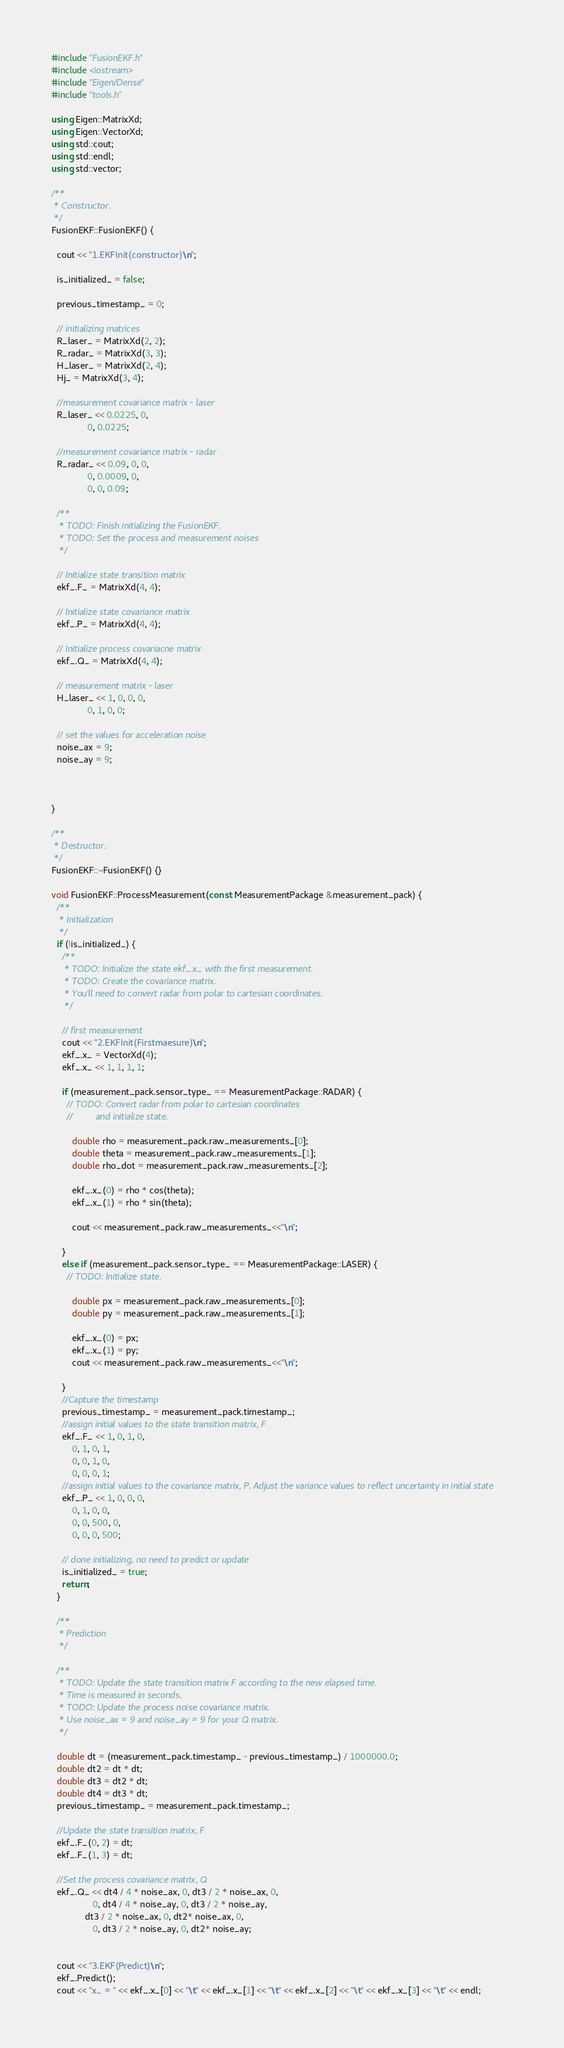Convert code to text. <code><loc_0><loc_0><loc_500><loc_500><_C++_>#include "FusionEKF.h"
#include <iostream>
#include "Eigen/Dense"
#include "tools.h"

using Eigen::MatrixXd;
using Eigen::VectorXd;
using std::cout;
using std::endl;
using std::vector;

/**
 * Constructor.
 */
FusionEKF::FusionEKF() {
  
  cout << "1.EKFInit(constructor)\n";
    
  is_initialized_ = false;

  previous_timestamp_ = 0;

  // initializing matrices
  R_laser_ = MatrixXd(2, 2);
  R_radar_ = MatrixXd(3, 3);
  H_laser_ = MatrixXd(2, 4);
  Hj_ = MatrixXd(3, 4);

  //measurement covariance matrix - laser
  R_laser_ << 0.0225, 0,
              0, 0.0225;

  //measurement covariance matrix - radar
  R_radar_ << 0.09, 0, 0,
              0, 0.0009, 0,
              0, 0, 0.09;

  /**
   * TODO: Finish initializing the FusionEKF.
   * TODO: Set the process and measurement noises
   */

  // Initialize state transition matrix
  ekf_.F_ = MatrixXd(4, 4);

  // Initialize state covariance matrix
  ekf_.P_ = MatrixXd(4, 4);

  // Initialize process covariacne matrix
  ekf_.Q_ = MatrixXd(4, 4);

  // measurement matrix - laser
  H_laser_ << 1, 0, 0, 0,
              0, 1, 0, 0;
  
  // set the values for acceleration noise
  noise_ax = 9;
  noise_ay = 9;



}

/**
 * Destructor.
 */
FusionEKF::~FusionEKF() {}

void FusionEKF::ProcessMeasurement(const MeasurementPackage &measurement_pack) {
  /**
   * Initialization
   */
  if (!is_initialized_) {
    /**
     * TODO: Initialize the state ekf_.x_ with the first measurement.
     * TODO: Create the covariance matrix.
     * You'll need to convert radar from polar to cartesian coordinates.
     */

    // first measurement
    cout << "2.EKFInit(Firstmaesure)\n";
    ekf_.x_ = VectorXd(4);
    ekf_.x_ << 1, 1, 1, 1;

    if (measurement_pack.sensor_type_ == MeasurementPackage::RADAR) {
      // TODO: Convert radar from polar to cartesian coordinates 
      //         and initialize state.

        double rho = measurement_pack.raw_measurements_[0];
        double theta = measurement_pack.raw_measurements_[1];
        double rho_dot = measurement_pack.raw_measurements_[2];
       
        ekf_.x_(0) = rho * cos(theta);
        ekf_.x_(1) = rho * sin(theta);

        cout << measurement_pack.raw_measurements_<<"\n";

    }
    else if (measurement_pack.sensor_type_ == MeasurementPackage::LASER) {
      // TODO: Initialize state.

        double px = measurement_pack.raw_measurements_[0];
        double py = measurement_pack.raw_measurements_[1];

        ekf_.x_(0) = px;
        ekf_.x_(1) = py;
        cout << measurement_pack.raw_measurements_<<"\n";

    }
    //Capture the timestamp
    previous_timestamp_ = measurement_pack.timestamp_;
    //assign initial values to the state transition matrix, F
    ekf_.F_ << 1, 0, 1, 0,
        0, 1, 0, 1,
        0, 0, 1, 0,
        0, 0, 0, 1;
    //assign initial values to the covariance matrix, P. Adjust the variance values to reflect uncertainty in initial state
    ekf_.P_ << 1, 0, 0, 0,
        0, 1, 0, 0,
        0, 0, 500, 0,
        0, 0, 0, 500;

    // done initializing, no need to predict or update
    is_initialized_ = true;
    return;
  }

  /**
   * Prediction
   */

  /**
   * TODO: Update the state transition matrix F according to the new elapsed time.
   * Time is measured in seconds.
   * TODO: Update the process noise covariance matrix.
   * Use noise_ax = 9 and noise_ay = 9 for your Q matrix.
   */

  double dt = (measurement_pack.timestamp_ - previous_timestamp_) / 1000000.0;
  double dt2 = dt * dt;
  double dt3 = dt2 * dt;
  double dt4 = dt3 * dt;
  previous_timestamp_ = measurement_pack.timestamp_;
  
  //Update the state transition matrix, F
  ekf_.F_(0, 2) = dt;
  ekf_.F_(1, 3) = dt;
  
  //Set the process covariance matrix, Q
  ekf_.Q_ << dt4 / 4 * noise_ax, 0, dt3 / 2 * noise_ax, 0,
                0, dt4 / 4 * noise_ay, 0, dt3 / 2 * noise_ay,
             dt3 / 2 * noise_ax, 0, dt2* noise_ax, 0,
                0, dt3 / 2 * noise_ay, 0, dt2* noise_ay;
  
  
  cout << "3.EKF(Predict)\n";
  ekf_.Predict();
  cout << "x_ = " << ekf_.x_[0] << "\t" << ekf_.x_[1] << "\t" << ekf_.x_[2] << "\t" << ekf_.x_[3] << "\t" << endl;</code> 